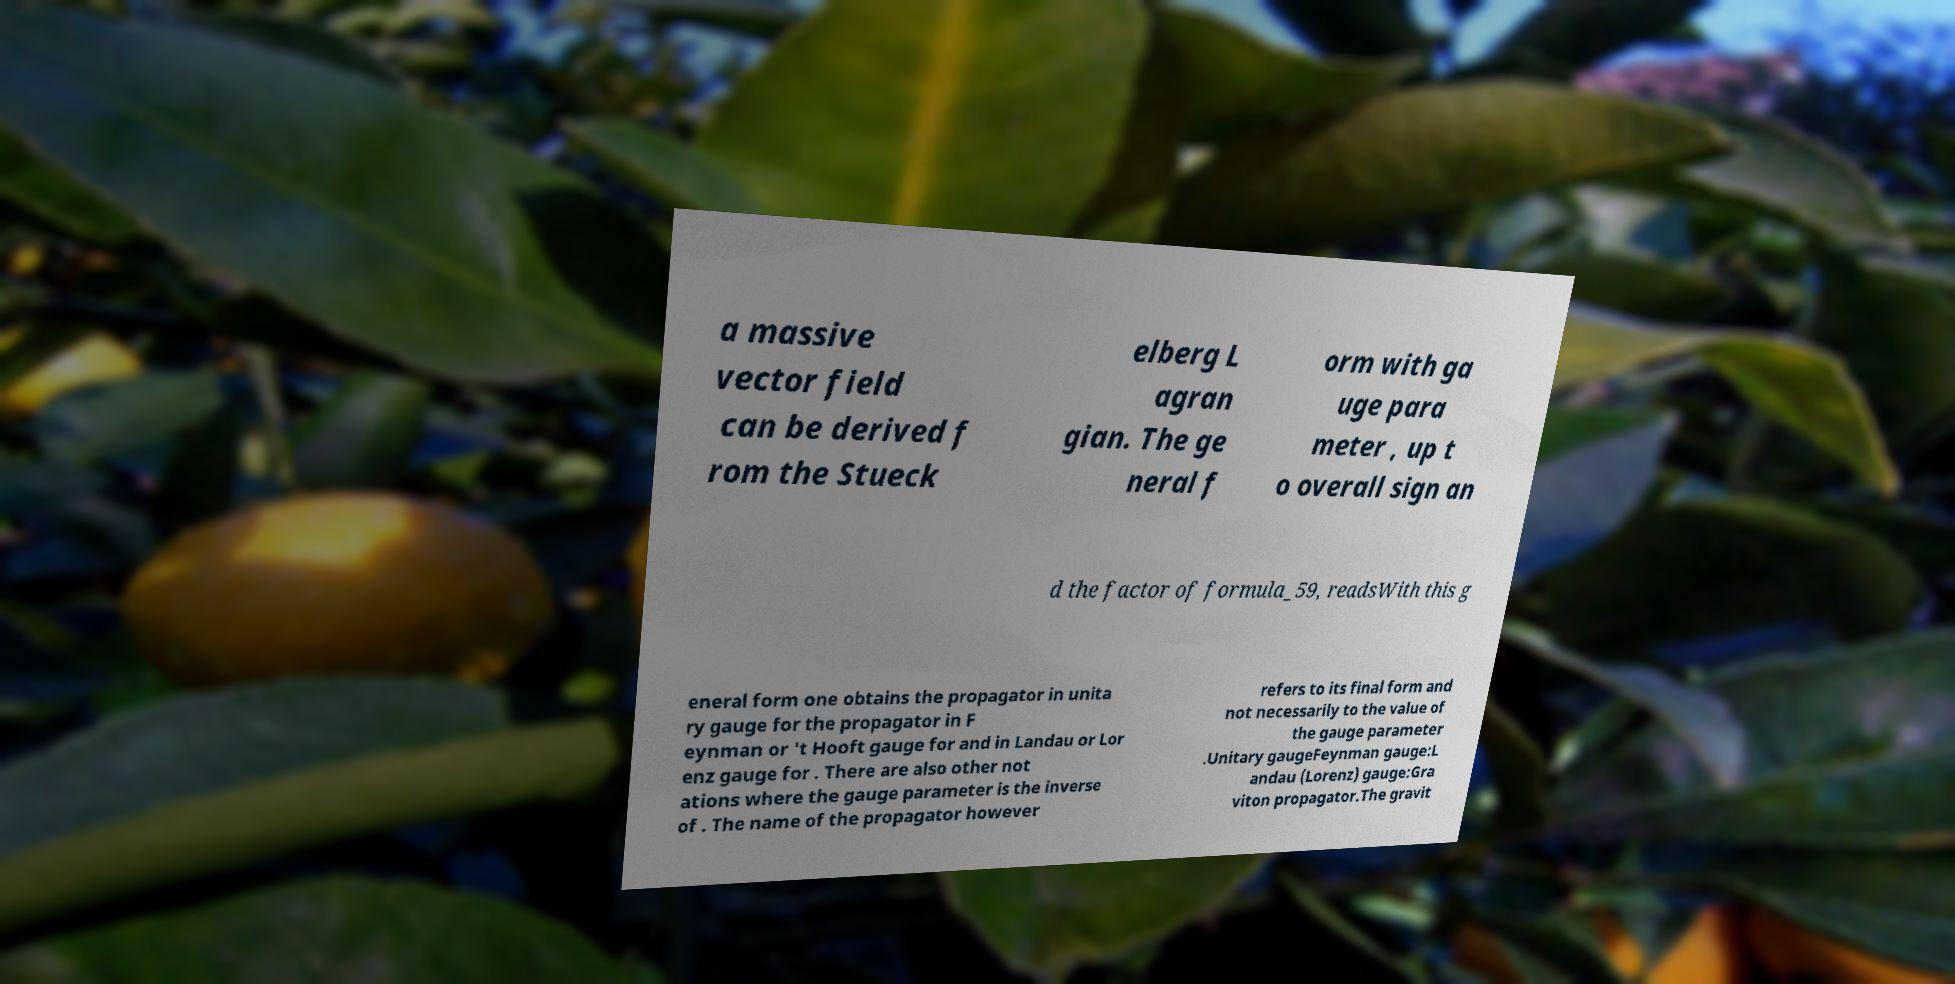Could you assist in decoding the text presented in this image and type it out clearly? a massive vector field can be derived f rom the Stueck elberg L agran gian. The ge neral f orm with ga uge para meter , up t o overall sign an d the factor of formula_59, readsWith this g eneral form one obtains the propagator in unita ry gauge for the propagator in F eynman or 't Hooft gauge for and in Landau or Lor enz gauge for . There are also other not ations where the gauge parameter is the inverse of . The name of the propagator however refers to its final form and not necessarily to the value of the gauge parameter .Unitary gaugeFeynman gauge:L andau (Lorenz) gauge:Gra viton propagator.The gravit 